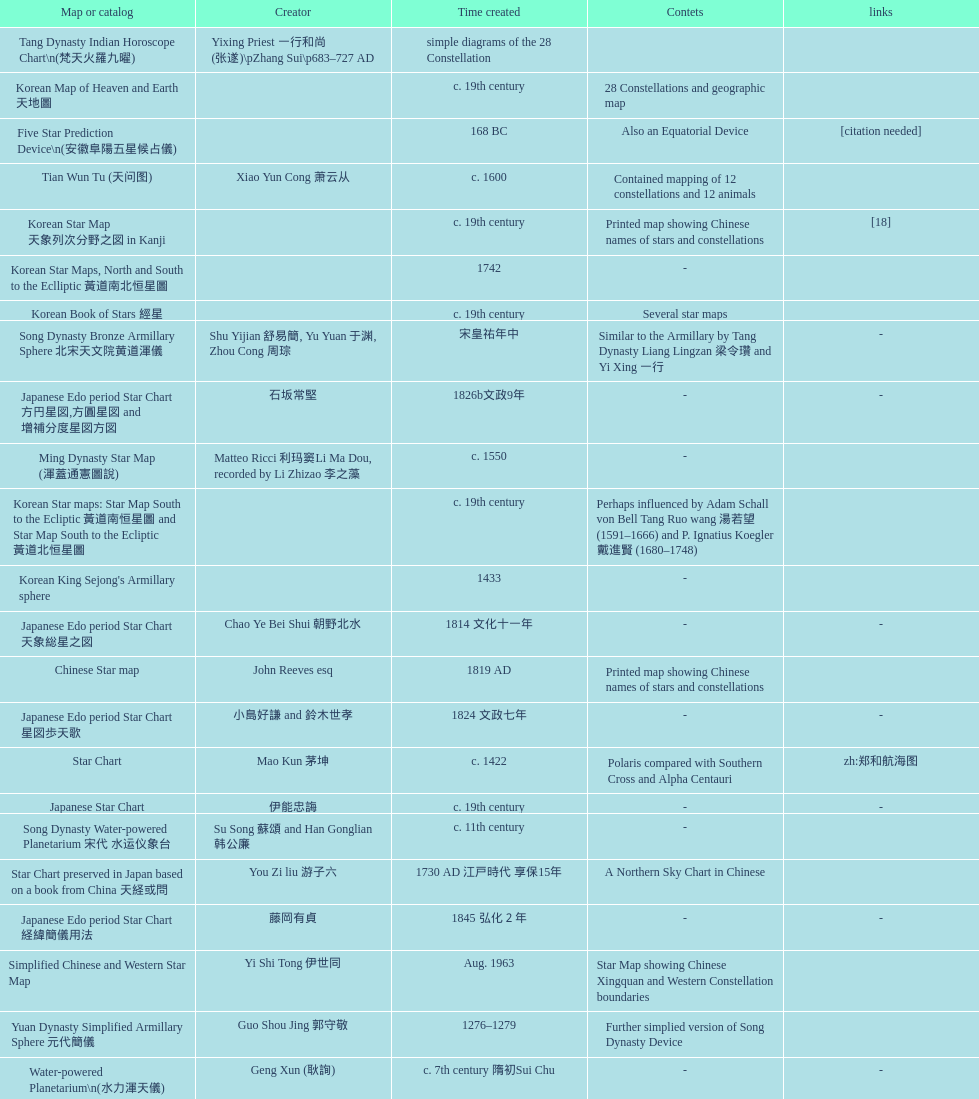What is the difference between the five star prediction device's date of creation and the han comet diagrams' date of creation? 25 years. 